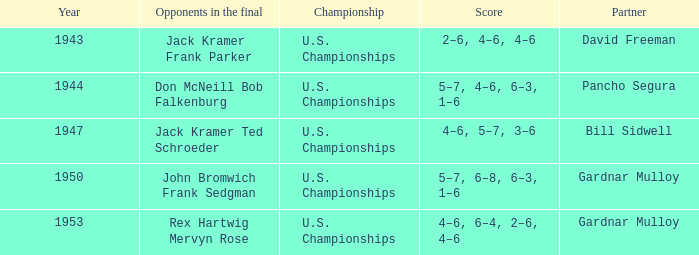Write the full table. {'header': ['Year', 'Opponents in the final', 'Championship', 'Score', 'Partner'], 'rows': [['1943', 'Jack Kramer Frank Parker', 'U.S. Championships', '2–6, 4–6, 4–6', 'David Freeman'], ['1944', 'Don McNeill Bob Falkenburg', 'U.S. Championships', '5–7, 4–6, 6–3, 1–6', 'Pancho Segura'], ['1947', 'Jack Kramer Ted Schroeder', 'U.S. Championships', '4–6, 5–7, 3–6', 'Bill Sidwell'], ['1950', 'John Bromwich Frank Sedgman', 'U.S. Championships', '5–7, 6–8, 6–3, 1–6', 'Gardnar Mulloy'], ['1953', 'Rex Hartwig Mervyn Rose', 'U.S. Championships', '4–6, 6–4, 2–6, 4–6', 'Gardnar Mulloy']]} Which Championship has a Score of 2–6, 4–6, 4–6? U.S. Championships. 